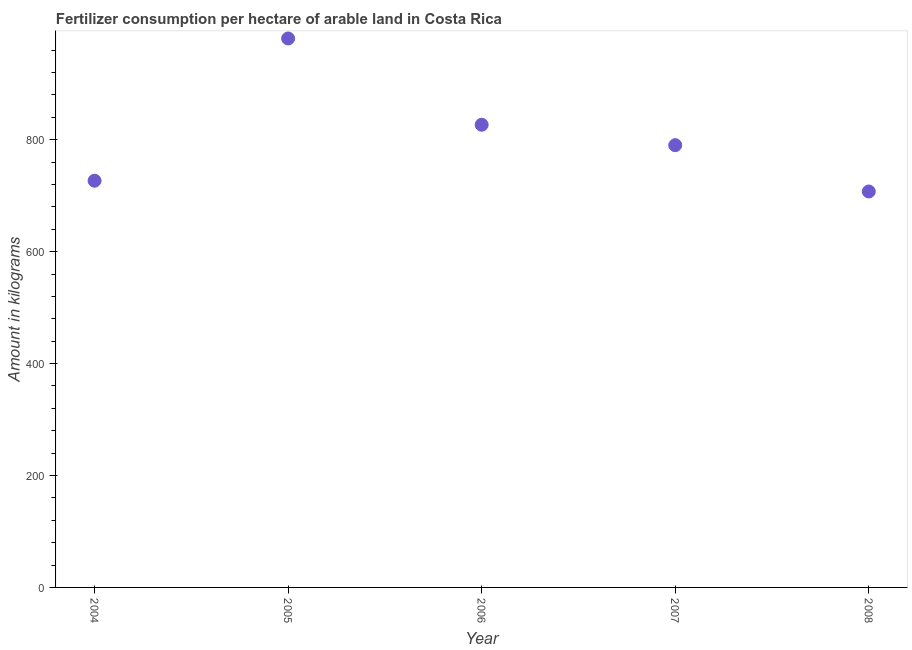What is the amount of fertilizer consumption in 2008?
Offer a terse response. 707.48. Across all years, what is the maximum amount of fertilizer consumption?
Provide a short and direct response. 980.88. Across all years, what is the minimum amount of fertilizer consumption?
Your answer should be compact. 707.48. In which year was the amount of fertilizer consumption minimum?
Ensure brevity in your answer.  2008. What is the sum of the amount of fertilizer consumption?
Provide a short and direct response. 4031.95. What is the difference between the amount of fertilizer consumption in 2004 and 2006?
Make the answer very short. -100.01. What is the average amount of fertilizer consumption per year?
Keep it short and to the point. 806.39. What is the median amount of fertilizer consumption?
Ensure brevity in your answer.  790.2. In how many years, is the amount of fertilizer consumption greater than 560 kg?
Provide a short and direct response. 5. What is the ratio of the amount of fertilizer consumption in 2006 to that in 2008?
Your answer should be very brief. 1.17. Is the amount of fertilizer consumption in 2004 less than that in 2007?
Keep it short and to the point. Yes. Is the difference between the amount of fertilizer consumption in 2005 and 2006 greater than the difference between any two years?
Your answer should be very brief. No. What is the difference between the highest and the second highest amount of fertilizer consumption?
Give a very brief answer. 154.17. What is the difference between the highest and the lowest amount of fertilizer consumption?
Give a very brief answer. 273.4. In how many years, is the amount of fertilizer consumption greater than the average amount of fertilizer consumption taken over all years?
Offer a very short reply. 2. Does the amount of fertilizer consumption monotonically increase over the years?
Offer a very short reply. No. How many years are there in the graph?
Your response must be concise. 5. Are the values on the major ticks of Y-axis written in scientific E-notation?
Offer a terse response. No. What is the title of the graph?
Make the answer very short. Fertilizer consumption per hectare of arable land in Costa Rica . What is the label or title of the Y-axis?
Ensure brevity in your answer.  Amount in kilograms. What is the Amount in kilograms in 2004?
Ensure brevity in your answer.  726.7. What is the Amount in kilograms in 2005?
Give a very brief answer. 980.88. What is the Amount in kilograms in 2006?
Make the answer very short. 826.7. What is the Amount in kilograms in 2007?
Offer a terse response. 790.2. What is the Amount in kilograms in 2008?
Make the answer very short. 707.48. What is the difference between the Amount in kilograms in 2004 and 2005?
Your answer should be compact. -254.18. What is the difference between the Amount in kilograms in 2004 and 2006?
Give a very brief answer. -100.01. What is the difference between the Amount in kilograms in 2004 and 2007?
Offer a very short reply. -63.5. What is the difference between the Amount in kilograms in 2004 and 2008?
Your answer should be compact. 19.22. What is the difference between the Amount in kilograms in 2005 and 2006?
Make the answer very short. 154.17. What is the difference between the Amount in kilograms in 2005 and 2007?
Offer a terse response. 190.68. What is the difference between the Amount in kilograms in 2005 and 2008?
Give a very brief answer. 273.4. What is the difference between the Amount in kilograms in 2006 and 2007?
Your answer should be compact. 36.51. What is the difference between the Amount in kilograms in 2006 and 2008?
Make the answer very short. 119.22. What is the difference between the Amount in kilograms in 2007 and 2008?
Provide a short and direct response. 82.72. What is the ratio of the Amount in kilograms in 2004 to that in 2005?
Keep it short and to the point. 0.74. What is the ratio of the Amount in kilograms in 2004 to that in 2006?
Ensure brevity in your answer.  0.88. What is the ratio of the Amount in kilograms in 2004 to that in 2008?
Provide a succinct answer. 1.03. What is the ratio of the Amount in kilograms in 2005 to that in 2006?
Your answer should be compact. 1.19. What is the ratio of the Amount in kilograms in 2005 to that in 2007?
Offer a terse response. 1.24. What is the ratio of the Amount in kilograms in 2005 to that in 2008?
Keep it short and to the point. 1.39. What is the ratio of the Amount in kilograms in 2006 to that in 2007?
Offer a very short reply. 1.05. What is the ratio of the Amount in kilograms in 2006 to that in 2008?
Keep it short and to the point. 1.17. What is the ratio of the Amount in kilograms in 2007 to that in 2008?
Ensure brevity in your answer.  1.12. 